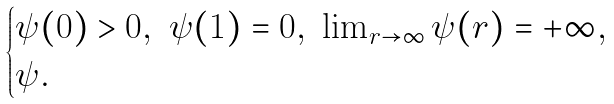<formula> <loc_0><loc_0><loc_500><loc_500>\begin{cases} \psi ( 0 ) > 0 , \ \psi ( 1 ) = 0 , \ \lim _ { r \to \infty } \psi ( r ) = + \infty , \\ \psi . \end{cases}</formula> 